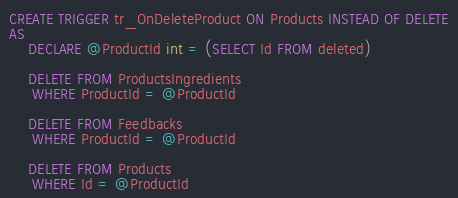<code> <loc_0><loc_0><loc_500><loc_500><_SQL_>CREATE TRIGGER tr_OnDeleteProduct ON Products INSTEAD OF DELETE
AS
	DECLARE @ProductId int = (SELECT Id FROM deleted)

	DELETE FROM ProductsIngredients
	 WHERE ProductId = @ProductId

	DELETE FROM Feedbacks
	 WHERE ProductId = @ProductId

	DELETE FROM Products
	 WHERE Id = @ProductId</code> 